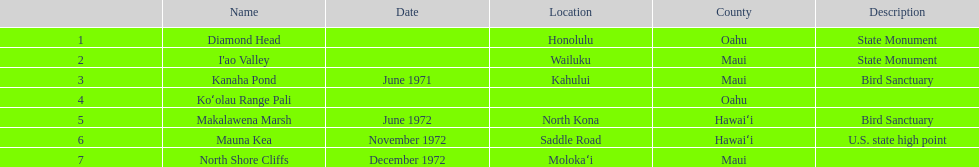What is the exclusive name displayed without a site? Koʻolau Range Pali. 